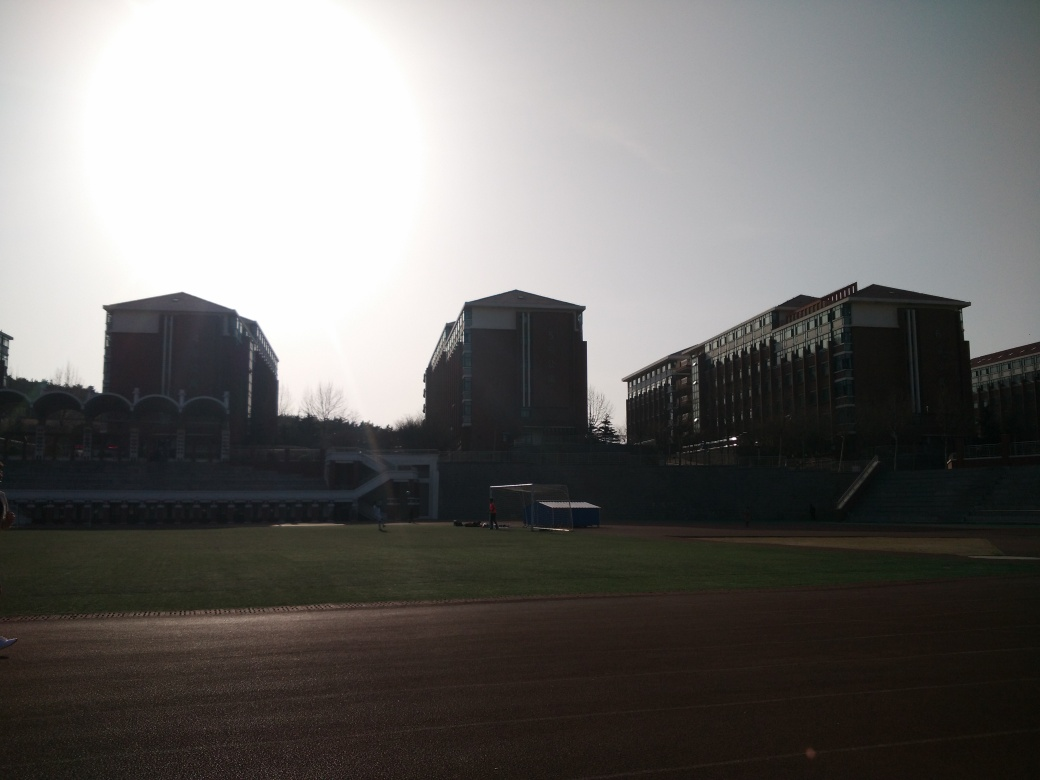What time of day does this photo appear to have been taken? The photo seems to have been taken in the early morning or late afternoon, as indicated by the long shadows cast on the ground and the warm, soft light from the sun positioned low on the horizon. 